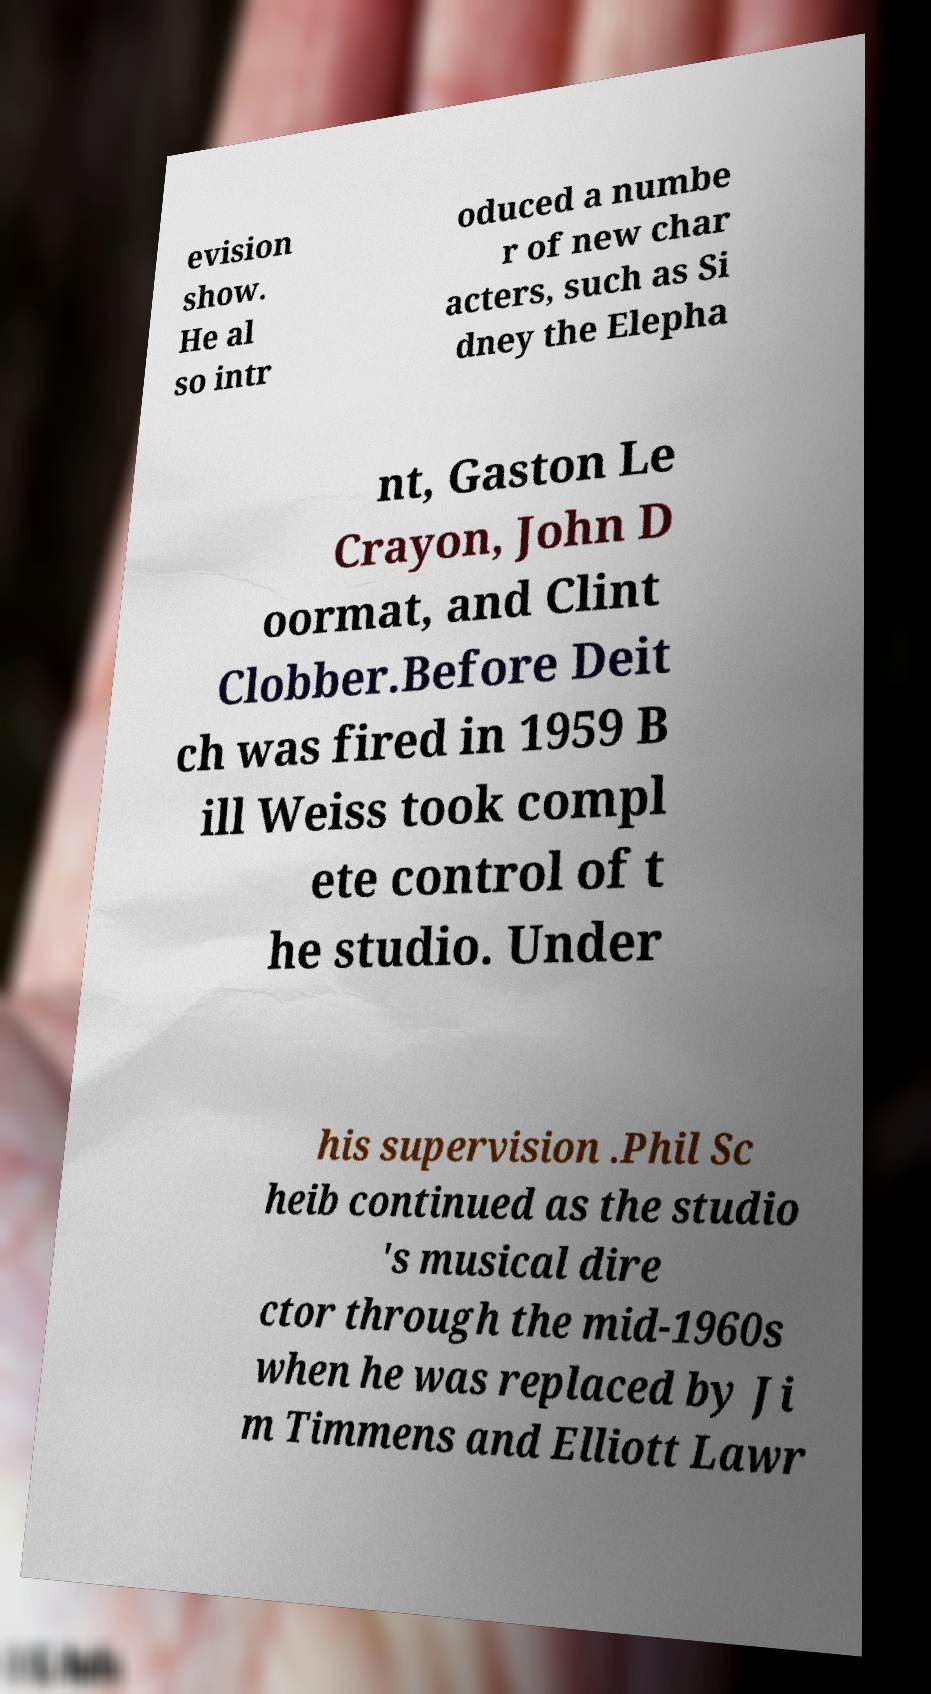I need the written content from this picture converted into text. Can you do that? evision show. He al so intr oduced a numbe r of new char acters, such as Si dney the Elepha nt, Gaston Le Crayon, John D oormat, and Clint Clobber.Before Deit ch was fired in 1959 B ill Weiss took compl ete control of t he studio. Under his supervision .Phil Sc heib continued as the studio 's musical dire ctor through the mid-1960s when he was replaced by Ji m Timmens and Elliott Lawr 